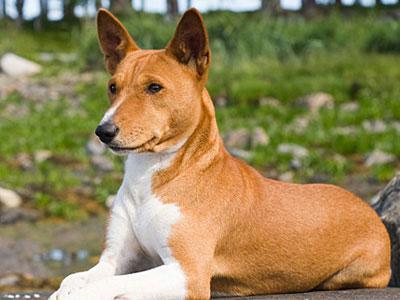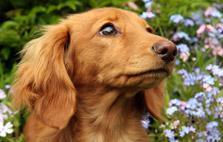The first image is the image on the left, the second image is the image on the right. Analyze the images presented: Is the assertion "The dog in the image on the right is turned toward and facing the camera." valid? Answer yes or no. No. 